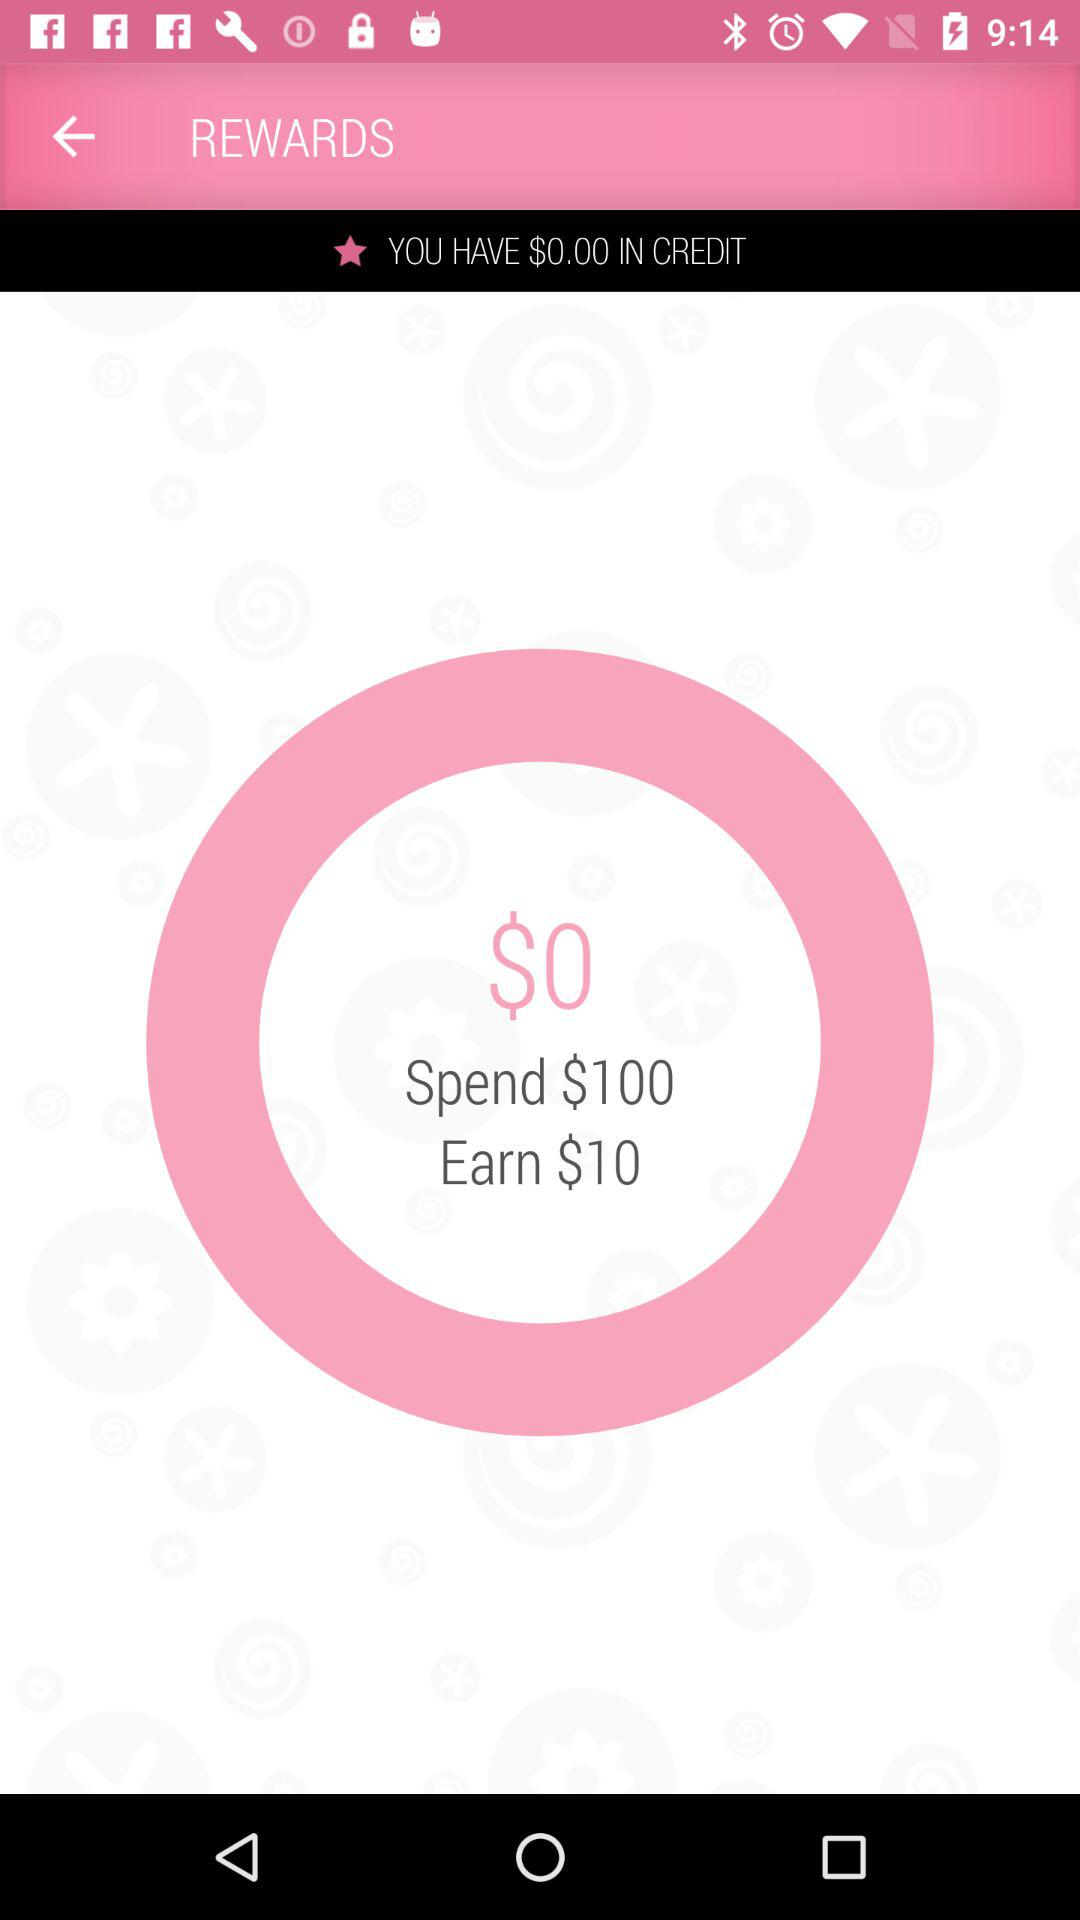How many dollars more do I need to spend to earn $10 in credit?
Answer the question using a single word or phrase. 100 